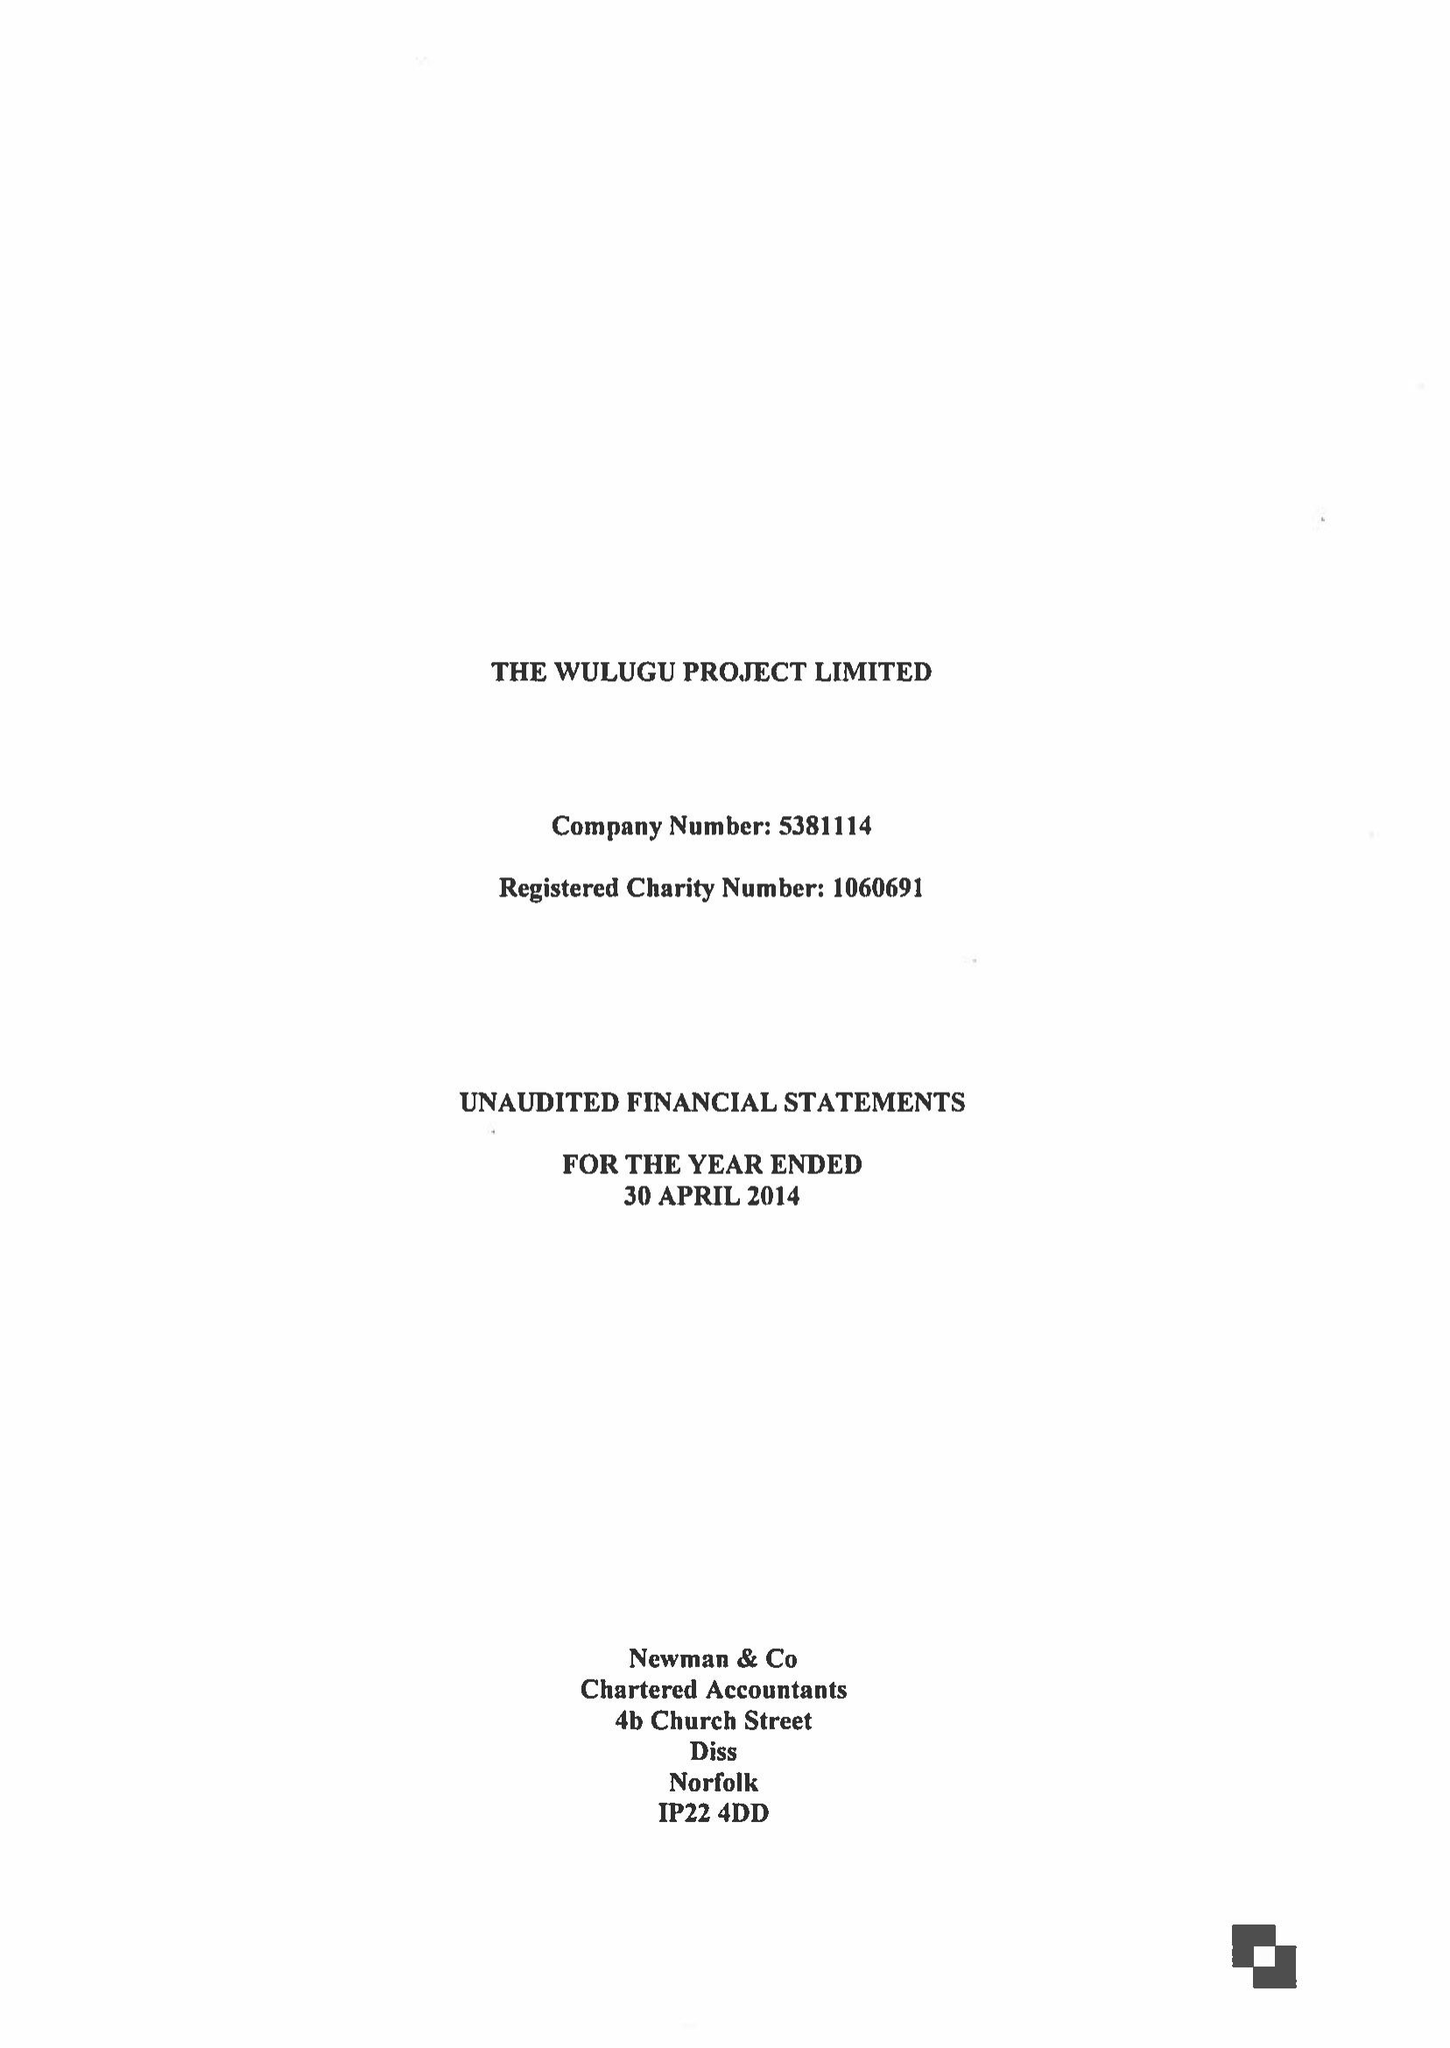What is the value for the spending_annually_in_british_pounds?
Answer the question using a single word or phrase. 144330.00 